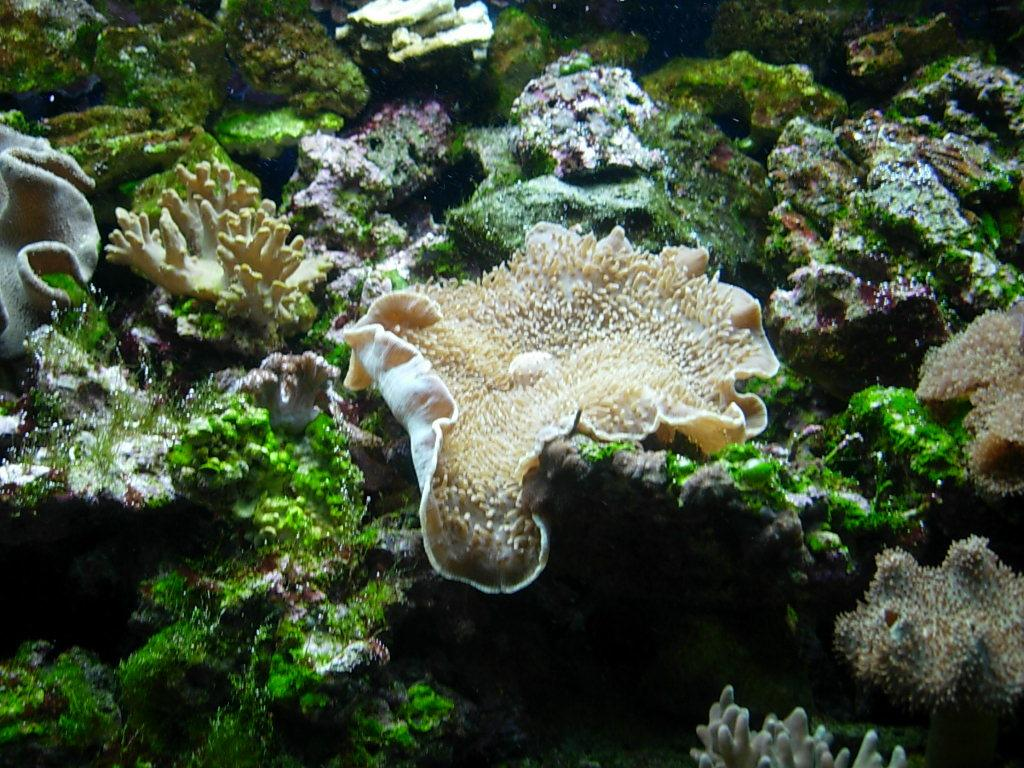What type of plants are visible in the foreground of the image? There are water plants in the foreground of the image. Where are the water plants located in relation to the water? The water plants are under the water. What type of acoustics can be heard from the scarecrow in the image? There is no scarecrow present in the image, so it is not possible to determine the acoustics. 